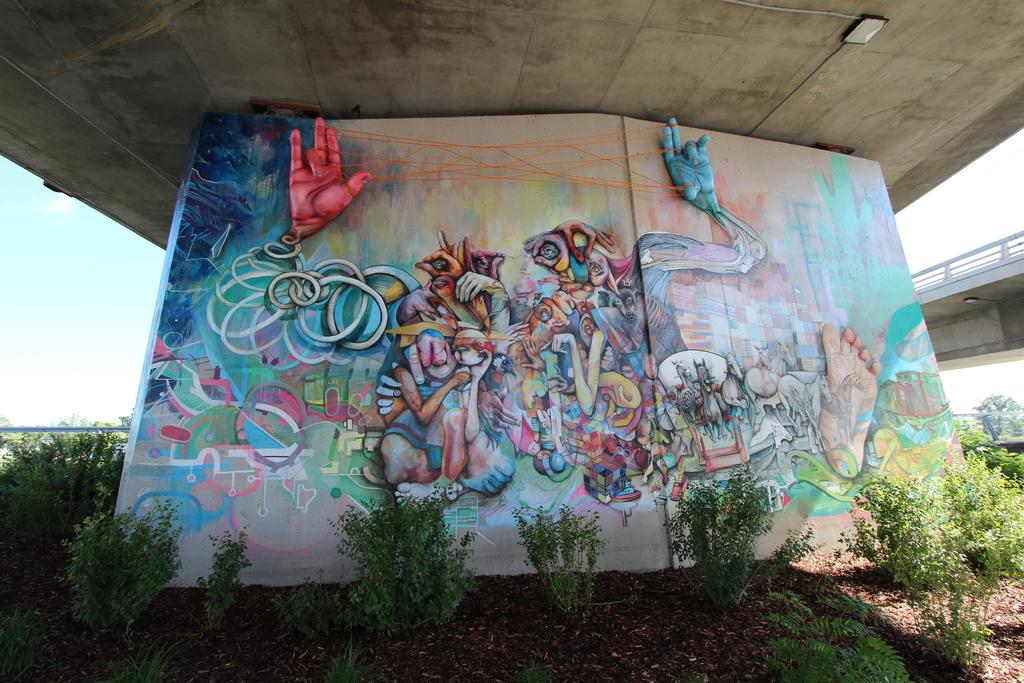What is depicted on the wall in the image? There is a painting on the wall in the image. What type of natural elements can be seen in the image? There are trees and a bridge in the image. What is visible in the background of the image? The sky is visible in the background of the image. What can be observed in the sky? There are clouds in the sky. Is there a recess happening in the image? There is no indication of a recess happening in the image. Can you see anyone swimming in the image? There is no water or swimming activity depicted in the image. 